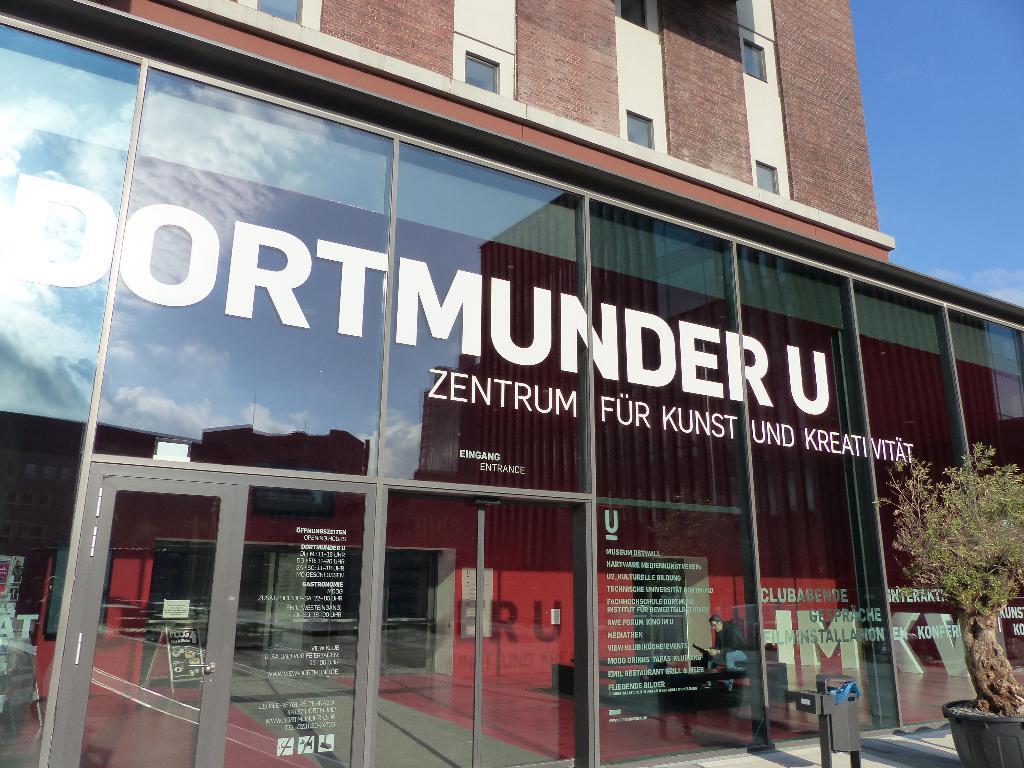Can you describe this image briefly? In this image, we can see a building and there is a tree and there is some text on the glass door and through the glass we can see a person and some stands. At the top, there is sky. 